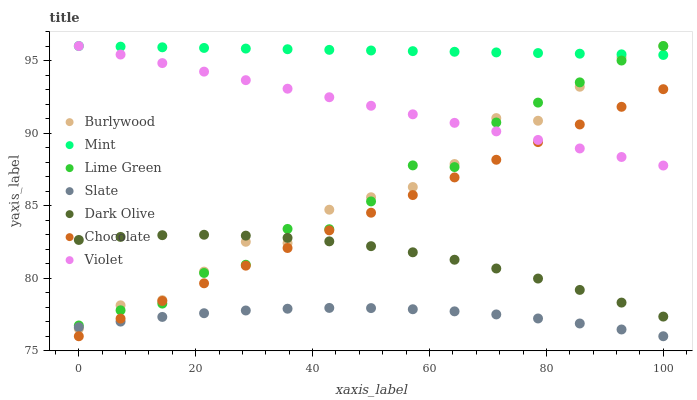Does Slate have the minimum area under the curve?
Answer yes or no. Yes. Does Mint have the maximum area under the curve?
Answer yes or no. Yes. Does Mint have the minimum area under the curve?
Answer yes or no. No. Does Slate have the maximum area under the curve?
Answer yes or no. No. Is Chocolate the smoothest?
Answer yes or no. Yes. Is Burlywood the roughest?
Answer yes or no. Yes. Is Mint the smoothest?
Answer yes or no. No. Is Mint the roughest?
Answer yes or no. No. Does Slate have the lowest value?
Answer yes or no. Yes. Does Mint have the lowest value?
Answer yes or no. No. Does Lime Green have the highest value?
Answer yes or no. Yes. Does Slate have the highest value?
Answer yes or no. No. Is Dark Olive less than Violet?
Answer yes or no. Yes. Is Mint greater than Slate?
Answer yes or no. Yes. Does Dark Olive intersect Lime Green?
Answer yes or no. Yes. Is Dark Olive less than Lime Green?
Answer yes or no. No. Is Dark Olive greater than Lime Green?
Answer yes or no. No. Does Dark Olive intersect Violet?
Answer yes or no. No. 